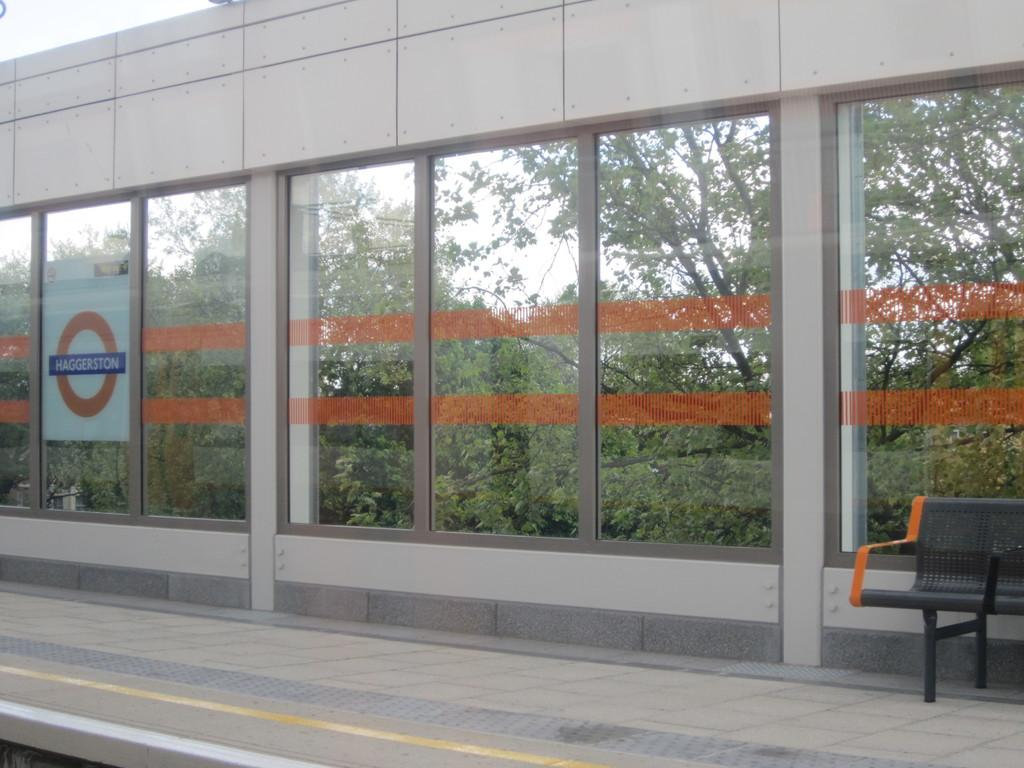What material is used for the walls of the building in the image? The walls of the building are made of glass. What can be seen outside the building? There is a walking path outside the building. Is there any seating available outside the building? Yes, there is a bench outside the building. What type of advice can be seen written on the glass walls of the building? There is no advice written on the glass walls of the building in the image. What kind of toys are scattered around the walking path outside the building? There are no toys present in the image; it only shows a building with glass walls, a walking path, and a bench. 